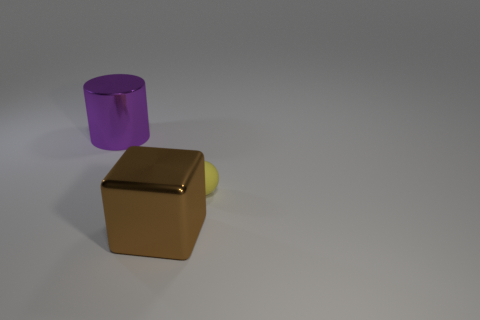What shape is the metallic object that is behind the object that is on the right side of the large brown cube?
Provide a short and direct response. Cylinder. Do the large thing that is to the left of the big brown thing and the brown block have the same material?
Your answer should be compact. Yes. What number of cyan things are either balls or big metal cubes?
Ensure brevity in your answer.  0. Are there any small things that have the same color as the large shiny cube?
Your answer should be very brief. No. Are there any balls made of the same material as the small yellow thing?
Provide a succinct answer. No. There is a object that is both behind the brown object and in front of the purple cylinder; what shape is it?
Offer a terse response. Sphere. How many large things are either brown things or metal cylinders?
Your answer should be compact. 2. What is the large brown thing made of?
Your response must be concise. Metal. What number of other things are there of the same shape as the tiny rubber object?
Provide a succinct answer. 0. What size is the shiny cube?
Your response must be concise. Large. 